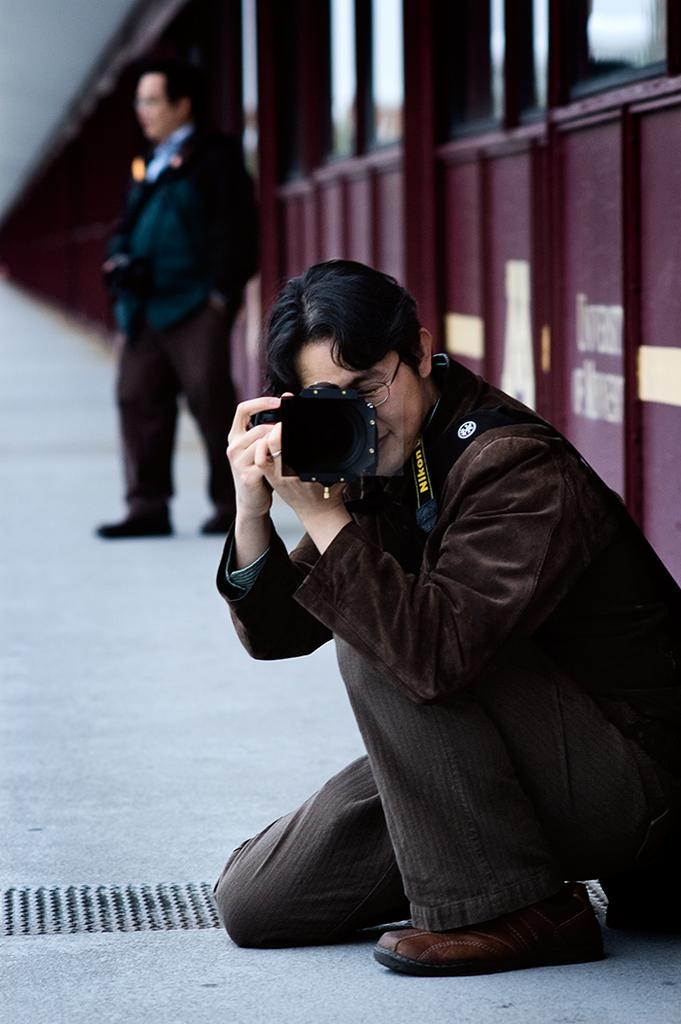How many people are in the image? There are two men in the image. What is one of the men doing in the image? One of the men is holding a camera. Can you describe the appearance of the man holding the camera? The man holding the camera is wearing glasses (specs). What is the title of the book the creator is holding in the image? There is no book or creator present in the image; it features two men, one of whom is holding a camera. 